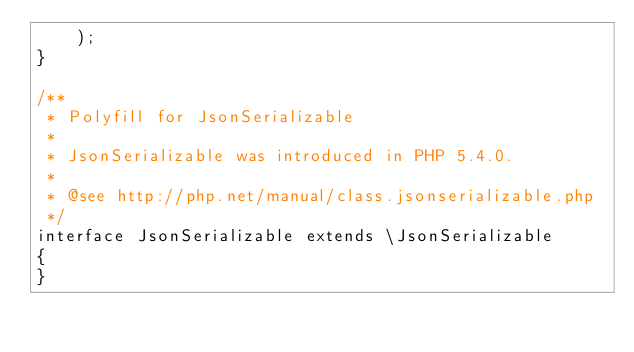Convert code to text. <code><loc_0><loc_0><loc_500><loc_500><_PHP_>    );
}

/**
 * Polyfill for JsonSerializable
 *
 * JsonSerializable was introduced in PHP 5.4.0.
 *
 * @see http://php.net/manual/class.jsonserializable.php
 */
interface JsonSerializable extends \JsonSerializable
{
}
</code> 